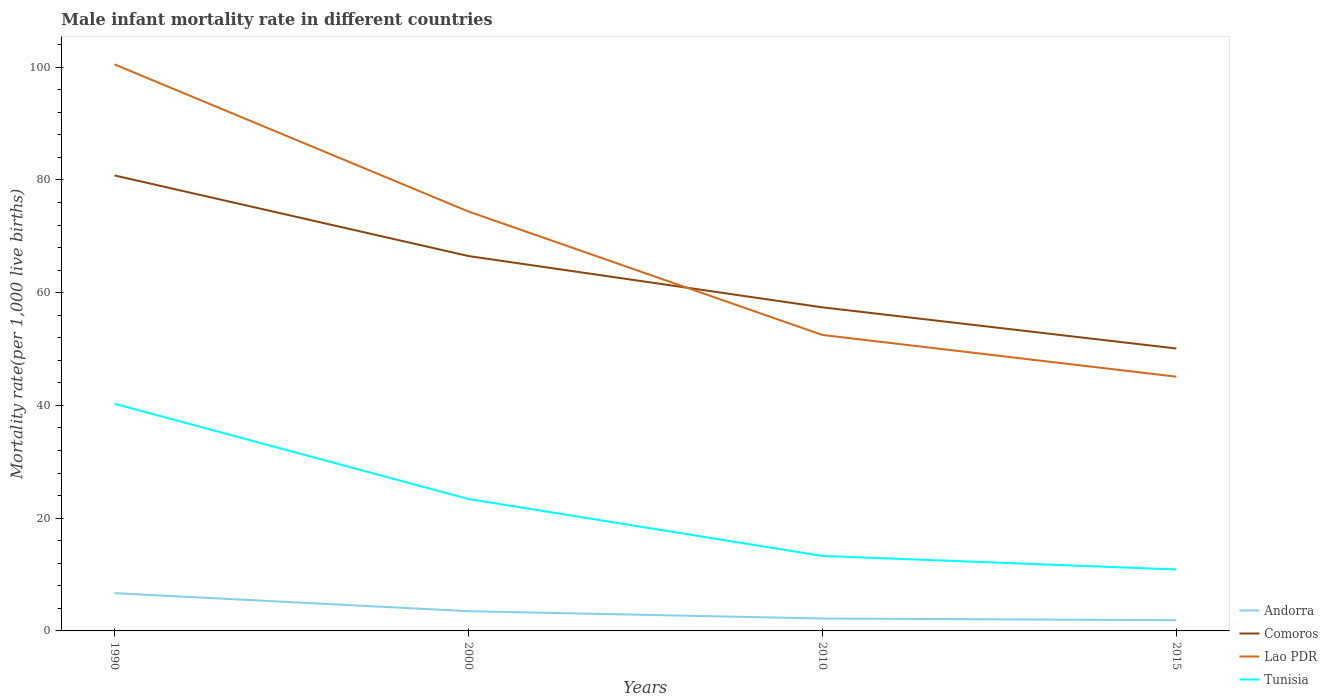How many different coloured lines are there?
Give a very brief answer. 4. Does the line corresponding to Andorra intersect with the line corresponding to Comoros?
Make the answer very short. No. Is the number of lines equal to the number of legend labels?
Offer a very short reply. Yes. Across all years, what is the maximum male infant mortality rate in Tunisia?
Give a very brief answer. 10.9. In which year was the male infant mortality rate in Comoros maximum?
Provide a succinct answer. 2015. What is the total male infant mortality rate in Andorra in the graph?
Make the answer very short. 1.3. What is the difference between the highest and the second highest male infant mortality rate in Tunisia?
Provide a succinct answer. 29.4. What is the difference between the highest and the lowest male infant mortality rate in Comoros?
Your answer should be compact. 2. What is the difference between two consecutive major ticks on the Y-axis?
Provide a succinct answer. 20. Are the values on the major ticks of Y-axis written in scientific E-notation?
Keep it short and to the point. No. Does the graph contain any zero values?
Your answer should be very brief. No. How many legend labels are there?
Offer a very short reply. 4. What is the title of the graph?
Offer a terse response. Male infant mortality rate in different countries. Does "Togo" appear as one of the legend labels in the graph?
Provide a succinct answer. No. What is the label or title of the X-axis?
Offer a very short reply. Years. What is the label or title of the Y-axis?
Offer a terse response. Mortality rate(per 1,0 live births). What is the Mortality rate(per 1,000 live births) of Andorra in 1990?
Offer a terse response. 6.7. What is the Mortality rate(per 1,000 live births) of Comoros in 1990?
Provide a succinct answer. 80.8. What is the Mortality rate(per 1,000 live births) in Lao PDR in 1990?
Give a very brief answer. 100.5. What is the Mortality rate(per 1,000 live births) of Tunisia in 1990?
Your response must be concise. 40.3. What is the Mortality rate(per 1,000 live births) of Comoros in 2000?
Your answer should be very brief. 66.5. What is the Mortality rate(per 1,000 live births) of Lao PDR in 2000?
Provide a succinct answer. 74.4. What is the Mortality rate(per 1,000 live births) in Tunisia in 2000?
Provide a succinct answer. 23.4. What is the Mortality rate(per 1,000 live births) of Andorra in 2010?
Your answer should be compact. 2.2. What is the Mortality rate(per 1,000 live births) in Comoros in 2010?
Provide a short and direct response. 57.4. What is the Mortality rate(per 1,000 live births) in Lao PDR in 2010?
Your answer should be very brief. 52.5. What is the Mortality rate(per 1,000 live births) of Comoros in 2015?
Provide a succinct answer. 50.1. What is the Mortality rate(per 1,000 live births) in Lao PDR in 2015?
Provide a short and direct response. 45.1. Across all years, what is the maximum Mortality rate(per 1,000 live births) in Comoros?
Keep it short and to the point. 80.8. Across all years, what is the maximum Mortality rate(per 1,000 live births) of Lao PDR?
Your answer should be compact. 100.5. Across all years, what is the maximum Mortality rate(per 1,000 live births) of Tunisia?
Provide a succinct answer. 40.3. Across all years, what is the minimum Mortality rate(per 1,000 live births) of Andorra?
Ensure brevity in your answer.  1.9. Across all years, what is the minimum Mortality rate(per 1,000 live births) in Comoros?
Keep it short and to the point. 50.1. Across all years, what is the minimum Mortality rate(per 1,000 live births) of Lao PDR?
Give a very brief answer. 45.1. What is the total Mortality rate(per 1,000 live births) in Andorra in the graph?
Ensure brevity in your answer.  14.3. What is the total Mortality rate(per 1,000 live births) in Comoros in the graph?
Provide a short and direct response. 254.8. What is the total Mortality rate(per 1,000 live births) of Lao PDR in the graph?
Keep it short and to the point. 272.5. What is the total Mortality rate(per 1,000 live births) in Tunisia in the graph?
Offer a very short reply. 87.9. What is the difference between the Mortality rate(per 1,000 live births) of Lao PDR in 1990 and that in 2000?
Make the answer very short. 26.1. What is the difference between the Mortality rate(per 1,000 live births) in Tunisia in 1990 and that in 2000?
Provide a short and direct response. 16.9. What is the difference between the Mortality rate(per 1,000 live births) of Andorra in 1990 and that in 2010?
Your answer should be very brief. 4.5. What is the difference between the Mortality rate(per 1,000 live births) of Comoros in 1990 and that in 2010?
Provide a succinct answer. 23.4. What is the difference between the Mortality rate(per 1,000 live births) in Andorra in 1990 and that in 2015?
Your answer should be very brief. 4.8. What is the difference between the Mortality rate(per 1,000 live births) of Comoros in 1990 and that in 2015?
Your response must be concise. 30.7. What is the difference between the Mortality rate(per 1,000 live births) in Lao PDR in 1990 and that in 2015?
Your answer should be compact. 55.4. What is the difference between the Mortality rate(per 1,000 live births) in Tunisia in 1990 and that in 2015?
Offer a terse response. 29.4. What is the difference between the Mortality rate(per 1,000 live births) of Andorra in 2000 and that in 2010?
Your response must be concise. 1.3. What is the difference between the Mortality rate(per 1,000 live births) of Comoros in 2000 and that in 2010?
Your response must be concise. 9.1. What is the difference between the Mortality rate(per 1,000 live births) in Lao PDR in 2000 and that in 2010?
Your response must be concise. 21.9. What is the difference between the Mortality rate(per 1,000 live births) of Tunisia in 2000 and that in 2010?
Give a very brief answer. 10.1. What is the difference between the Mortality rate(per 1,000 live births) in Lao PDR in 2000 and that in 2015?
Make the answer very short. 29.3. What is the difference between the Mortality rate(per 1,000 live births) of Lao PDR in 2010 and that in 2015?
Keep it short and to the point. 7.4. What is the difference between the Mortality rate(per 1,000 live births) in Andorra in 1990 and the Mortality rate(per 1,000 live births) in Comoros in 2000?
Offer a terse response. -59.8. What is the difference between the Mortality rate(per 1,000 live births) of Andorra in 1990 and the Mortality rate(per 1,000 live births) of Lao PDR in 2000?
Give a very brief answer. -67.7. What is the difference between the Mortality rate(per 1,000 live births) of Andorra in 1990 and the Mortality rate(per 1,000 live births) of Tunisia in 2000?
Provide a succinct answer. -16.7. What is the difference between the Mortality rate(per 1,000 live births) in Comoros in 1990 and the Mortality rate(per 1,000 live births) in Lao PDR in 2000?
Keep it short and to the point. 6.4. What is the difference between the Mortality rate(per 1,000 live births) of Comoros in 1990 and the Mortality rate(per 1,000 live births) of Tunisia in 2000?
Give a very brief answer. 57.4. What is the difference between the Mortality rate(per 1,000 live births) of Lao PDR in 1990 and the Mortality rate(per 1,000 live births) of Tunisia in 2000?
Your answer should be very brief. 77.1. What is the difference between the Mortality rate(per 1,000 live births) in Andorra in 1990 and the Mortality rate(per 1,000 live births) in Comoros in 2010?
Provide a succinct answer. -50.7. What is the difference between the Mortality rate(per 1,000 live births) of Andorra in 1990 and the Mortality rate(per 1,000 live births) of Lao PDR in 2010?
Ensure brevity in your answer.  -45.8. What is the difference between the Mortality rate(per 1,000 live births) in Comoros in 1990 and the Mortality rate(per 1,000 live births) in Lao PDR in 2010?
Your answer should be compact. 28.3. What is the difference between the Mortality rate(per 1,000 live births) of Comoros in 1990 and the Mortality rate(per 1,000 live births) of Tunisia in 2010?
Offer a terse response. 67.5. What is the difference between the Mortality rate(per 1,000 live births) of Lao PDR in 1990 and the Mortality rate(per 1,000 live births) of Tunisia in 2010?
Provide a short and direct response. 87.2. What is the difference between the Mortality rate(per 1,000 live births) in Andorra in 1990 and the Mortality rate(per 1,000 live births) in Comoros in 2015?
Your answer should be compact. -43.4. What is the difference between the Mortality rate(per 1,000 live births) of Andorra in 1990 and the Mortality rate(per 1,000 live births) of Lao PDR in 2015?
Offer a very short reply. -38.4. What is the difference between the Mortality rate(per 1,000 live births) in Andorra in 1990 and the Mortality rate(per 1,000 live births) in Tunisia in 2015?
Your answer should be compact. -4.2. What is the difference between the Mortality rate(per 1,000 live births) in Comoros in 1990 and the Mortality rate(per 1,000 live births) in Lao PDR in 2015?
Your answer should be very brief. 35.7. What is the difference between the Mortality rate(per 1,000 live births) of Comoros in 1990 and the Mortality rate(per 1,000 live births) of Tunisia in 2015?
Offer a terse response. 69.9. What is the difference between the Mortality rate(per 1,000 live births) in Lao PDR in 1990 and the Mortality rate(per 1,000 live births) in Tunisia in 2015?
Your answer should be very brief. 89.6. What is the difference between the Mortality rate(per 1,000 live births) in Andorra in 2000 and the Mortality rate(per 1,000 live births) in Comoros in 2010?
Your answer should be compact. -53.9. What is the difference between the Mortality rate(per 1,000 live births) of Andorra in 2000 and the Mortality rate(per 1,000 live births) of Lao PDR in 2010?
Offer a terse response. -49. What is the difference between the Mortality rate(per 1,000 live births) of Andorra in 2000 and the Mortality rate(per 1,000 live births) of Tunisia in 2010?
Offer a terse response. -9.8. What is the difference between the Mortality rate(per 1,000 live births) of Comoros in 2000 and the Mortality rate(per 1,000 live births) of Tunisia in 2010?
Provide a succinct answer. 53.2. What is the difference between the Mortality rate(per 1,000 live births) of Lao PDR in 2000 and the Mortality rate(per 1,000 live births) of Tunisia in 2010?
Give a very brief answer. 61.1. What is the difference between the Mortality rate(per 1,000 live births) in Andorra in 2000 and the Mortality rate(per 1,000 live births) in Comoros in 2015?
Provide a succinct answer. -46.6. What is the difference between the Mortality rate(per 1,000 live births) in Andorra in 2000 and the Mortality rate(per 1,000 live births) in Lao PDR in 2015?
Give a very brief answer. -41.6. What is the difference between the Mortality rate(per 1,000 live births) of Comoros in 2000 and the Mortality rate(per 1,000 live births) of Lao PDR in 2015?
Offer a terse response. 21.4. What is the difference between the Mortality rate(per 1,000 live births) of Comoros in 2000 and the Mortality rate(per 1,000 live births) of Tunisia in 2015?
Your response must be concise. 55.6. What is the difference between the Mortality rate(per 1,000 live births) of Lao PDR in 2000 and the Mortality rate(per 1,000 live births) of Tunisia in 2015?
Your answer should be very brief. 63.5. What is the difference between the Mortality rate(per 1,000 live births) of Andorra in 2010 and the Mortality rate(per 1,000 live births) of Comoros in 2015?
Make the answer very short. -47.9. What is the difference between the Mortality rate(per 1,000 live births) in Andorra in 2010 and the Mortality rate(per 1,000 live births) in Lao PDR in 2015?
Provide a short and direct response. -42.9. What is the difference between the Mortality rate(per 1,000 live births) of Andorra in 2010 and the Mortality rate(per 1,000 live births) of Tunisia in 2015?
Your answer should be compact. -8.7. What is the difference between the Mortality rate(per 1,000 live births) in Comoros in 2010 and the Mortality rate(per 1,000 live births) in Lao PDR in 2015?
Keep it short and to the point. 12.3. What is the difference between the Mortality rate(per 1,000 live births) in Comoros in 2010 and the Mortality rate(per 1,000 live births) in Tunisia in 2015?
Your answer should be very brief. 46.5. What is the difference between the Mortality rate(per 1,000 live births) of Lao PDR in 2010 and the Mortality rate(per 1,000 live births) of Tunisia in 2015?
Keep it short and to the point. 41.6. What is the average Mortality rate(per 1,000 live births) of Andorra per year?
Keep it short and to the point. 3.58. What is the average Mortality rate(per 1,000 live births) of Comoros per year?
Make the answer very short. 63.7. What is the average Mortality rate(per 1,000 live births) of Lao PDR per year?
Offer a terse response. 68.12. What is the average Mortality rate(per 1,000 live births) in Tunisia per year?
Ensure brevity in your answer.  21.98. In the year 1990, what is the difference between the Mortality rate(per 1,000 live births) of Andorra and Mortality rate(per 1,000 live births) of Comoros?
Offer a terse response. -74.1. In the year 1990, what is the difference between the Mortality rate(per 1,000 live births) in Andorra and Mortality rate(per 1,000 live births) in Lao PDR?
Your answer should be very brief. -93.8. In the year 1990, what is the difference between the Mortality rate(per 1,000 live births) of Andorra and Mortality rate(per 1,000 live births) of Tunisia?
Provide a succinct answer. -33.6. In the year 1990, what is the difference between the Mortality rate(per 1,000 live births) in Comoros and Mortality rate(per 1,000 live births) in Lao PDR?
Ensure brevity in your answer.  -19.7. In the year 1990, what is the difference between the Mortality rate(per 1,000 live births) of Comoros and Mortality rate(per 1,000 live births) of Tunisia?
Your answer should be compact. 40.5. In the year 1990, what is the difference between the Mortality rate(per 1,000 live births) in Lao PDR and Mortality rate(per 1,000 live births) in Tunisia?
Your answer should be very brief. 60.2. In the year 2000, what is the difference between the Mortality rate(per 1,000 live births) in Andorra and Mortality rate(per 1,000 live births) in Comoros?
Your answer should be compact. -63. In the year 2000, what is the difference between the Mortality rate(per 1,000 live births) in Andorra and Mortality rate(per 1,000 live births) in Lao PDR?
Offer a terse response. -70.9. In the year 2000, what is the difference between the Mortality rate(per 1,000 live births) of Andorra and Mortality rate(per 1,000 live births) of Tunisia?
Keep it short and to the point. -19.9. In the year 2000, what is the difference between the Mortality rate(per 1,000 live births) in Comoros and Mortality rate(per 1,000 live births) in Tunisia?
Your answer should be compact. 43.1. In the year 2000, what is the difference between the Mortality rate(per 1,000 live births) in Lao PDR and Mortality rate(per 1,000 live births) in Tunisia?
Give a very brief answer. 51. In the year 2010, what is the difference between the Mortality rate(per 1,000 live births) in Andorra and Mortality rate(per 1,000 live births) in Comoros?
Offer a very short reply. -55.2. In the year 2010, what is the difference between the Mortality rate(per 1,000 live births) in Andorra and Mortality rate(per 1,000 live births) in Lao PDR?
Provide a succinct answer. -50.3. In the year 2010, what is the difference between the Mortality rate(per 1,000 live births) of Comoros and Mortality rate(per 1,000 live births) of Tunisia?
Provide a succinct answer. 44.1. In the year 2010, what is the difference between the Mortality rate(per 1,000 live births) in Lao PDR and Mortality rate(per 1,000 live births) in Tunisia?
Give a very brief answer. 39.2. In the year 2015, what is the difference between the Mortality rate(per 1,000 live births) of Andorra and Mortality rate(per 1,000 live births) of Comoros?
Your answer should be compact. -48.2. In the year 2015, what is the difference between the Mortality rate(per 1,000 live births) of Andorra and Mortality rate(per 1,000 live births) of Lao PDR?
Give a very brief answer. -43.2. In the year 2015, what is the difference between the Mortality rate(per 1,000 live births) of Andorra and Mortality rate(per 1,000 live births) of Tunisia?
Offer a terse response. -9. In the year 2015, what is the difference between the Mortality rate(per 1,000 live births) in Comoros and Mortality rate(per 1,000 live births) in Lao PDR?
Ensure brevity in your answer.  5. In the year 2015, what is the difference between the Mortality rate(per 1,000 live births) of Comoros and Mortality rate(per 1,000 live births) of Tunisia?
Your response must be concise. 39.2. In the year 2015, what is the difference between the Mortality rate(per 1,000 live births) in Lao PDR and Mortality rate(per 1,000 live births) in Tunisia?
Give a very brief answer. 34.2. What is the ratio of the Mortality rate(per 1,000 live births) in Andorra in 1990 to that in 2000?
Offer a very short reply. 1.91. What is the ratio of the Mortality rate(per 1,000 live births) in Comoros in 1990 to that in 2000?
Offer a very short reply. 1.22. What is the ratio of the Mortality rate(per 1,000 live births) of Lao PDR in 1990 to that in 2000?
Keep it short and to the point. 1.35. What is the ratio of the Mortality rate(per 1,000 live births) in Tunisia in 1990 to that in 2000?
Your response must be concise. 1.72. What is the ratio of the Mortality rate(per 1,000 live births) in Andorra in 1990 to that in 2010?
Make the answer very short. 3.05. What is the ratio of the Mortality rate(per 1,000 live births) in Comoros in 1990 to that in 2010?
Provide a succinct answer. 1.41. What is the ratio of the Mortality rate(per 1,000 live births) of Lao PDR in 1990 to that in 2010?
Provide a short and direct response. 1.91. What is the ratio of the Mortality rate(per 1,000 live births) of Tunisia in 1990 to that in 2010?
Offer a terse response. 3.03. What is the ratio of the Mortality rate(per 1,000 live births) of Andorra in 1990 to that in 2015?
Provide a short and direct response. 3.53. What is the ratio of the Mortality rate(per 1,000 live births) of Comoros in 1990 to that in 2015?
Provide a short and direct response. 1.61. What is the ratio of the Mortality rate(per 1,000 live births) of Lao PDR in 1990 to that in 2015?
Your answer should be very brief. 2.23. What is the ratio of the Mortality rate(per 1,000 live births) in Tunisia in 1990 to that in 2015?
Make the answer very short. 3.7. What is the ratio of the Mortality rate(per 1,000 live births) in Andorra in 2000 to that in 2010?
Your answer should be very brief. 1.59. What is the ratio of the Mortality rate(per 1,000 live births) of Comoros in 2000 to that in 2010?
Give a very brief answer. 1.16. What is the ratio of the Mortality rate(per 1,000 live births) of Lao PDR in 2000 to that in 2010?
Keep it short and to the point. 1.42. What is the ratio of the Mortality rate(per 1,000 live births) in Tunisia in 2000 to that in 2010?
Your response must be concise. 1.76. What is the ratio of the Mortality rate(per 1,000 live births) of Andorra in 2000 to that in 2015?
Offer a terse response. 1.84. What is the ratio of the Mortality rate(per 1,000 live births) of Comoros in 2000 to that in 2015?
Provide a short and direct response. 1.33. What is the ratio of the Mortality rate(per 1,000 live births) in Lao PDR in 2000 to that in 2015?
Offer a terse response. 1.65. What is the ratio of the Mortality rate(per 1,000 live births) of Tunisia in 2000 to that in 2015?
Your response must be concise. 2.15. What is the ratio of the Mortality rate(per 1,000 live births) of Andorra in 2010 to that in 2015?
Make the answer very short. 1.16. What is the ratio of the Mortality rate(per 1,000 live births) in Comoros in 2010 to that in 2015?
Offer a very short reply. 1.15. What is the ratio of the Mortality rate(per 1,000 live births) in Lao PDR in 2010 to that in 2015?
Make the answer very short. 1.16. What is the ratio of the Mortality rate(per 1,000 live births) in Tunisia in 2010 to that in 2015?
Your answer should be very brief. 1.22. What is the difference between the highest and the second highest Mortality rate(per 1,000 live births) in Lao PDR?
Your answer should be compact. 26.1. What is the difference between the highest and the lowest Mortality rate(per 1,000 live births) in Comoros?
Your answer should be very brief. 30.7. What is the difference between the highest and the lowest Mortality rate(per 1,000 live births) in Lao PDR?
Provide a short and direct response. 55.4. What is the difference between the highest and the lowest Mortality rate(per 1,000 live births) in Tunisia?
Offer a terse response. 29.4. 